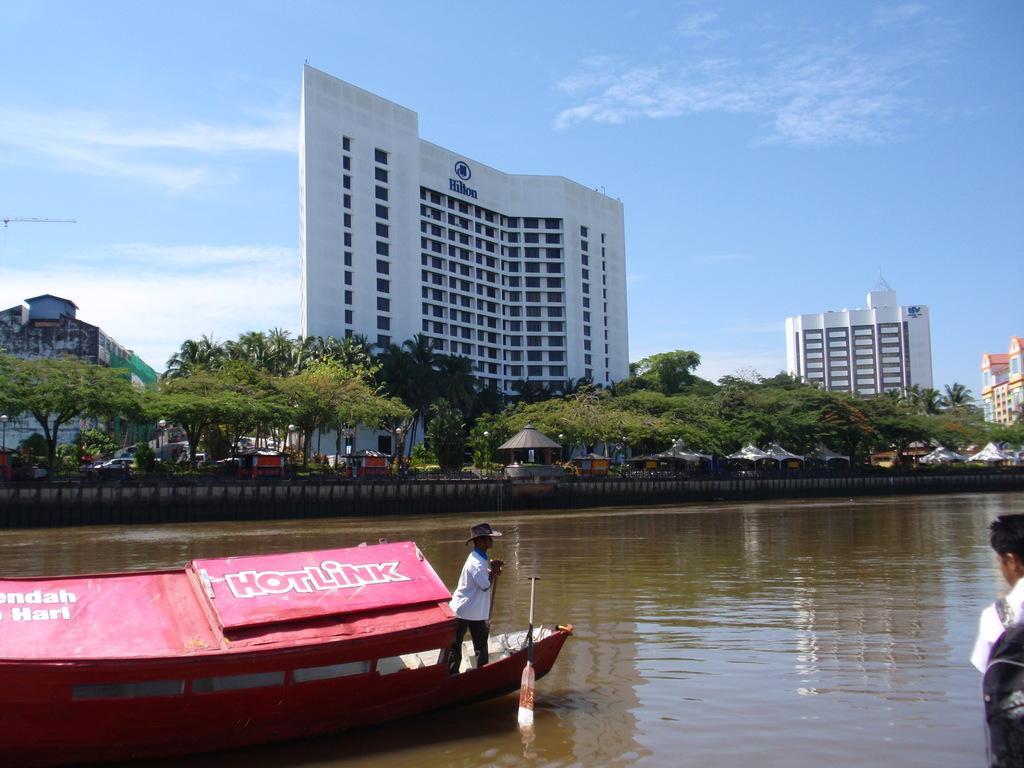Describe this image in one or two sentences. In this image at the bottom there is a river, and in the river there is a ship. In the ship there is one person and on the right side there is another person, in the background there is a wall, trees, tents, vehicles, poles and buildings. At the top there is sky. 